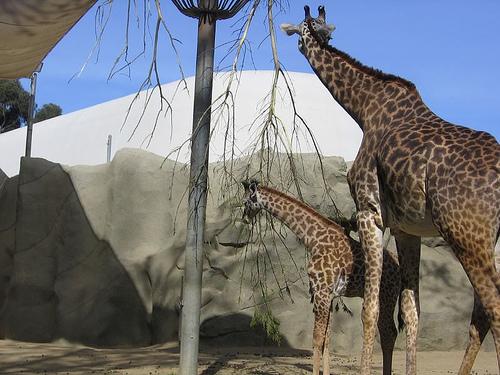How many giraffes are there?
Give a very brief answer. 2. What animal is here?
Short answer required. Giraffe. How many animals?
Concise answer only. 2. Is this at a zoo?
Be succinct. Yes. 